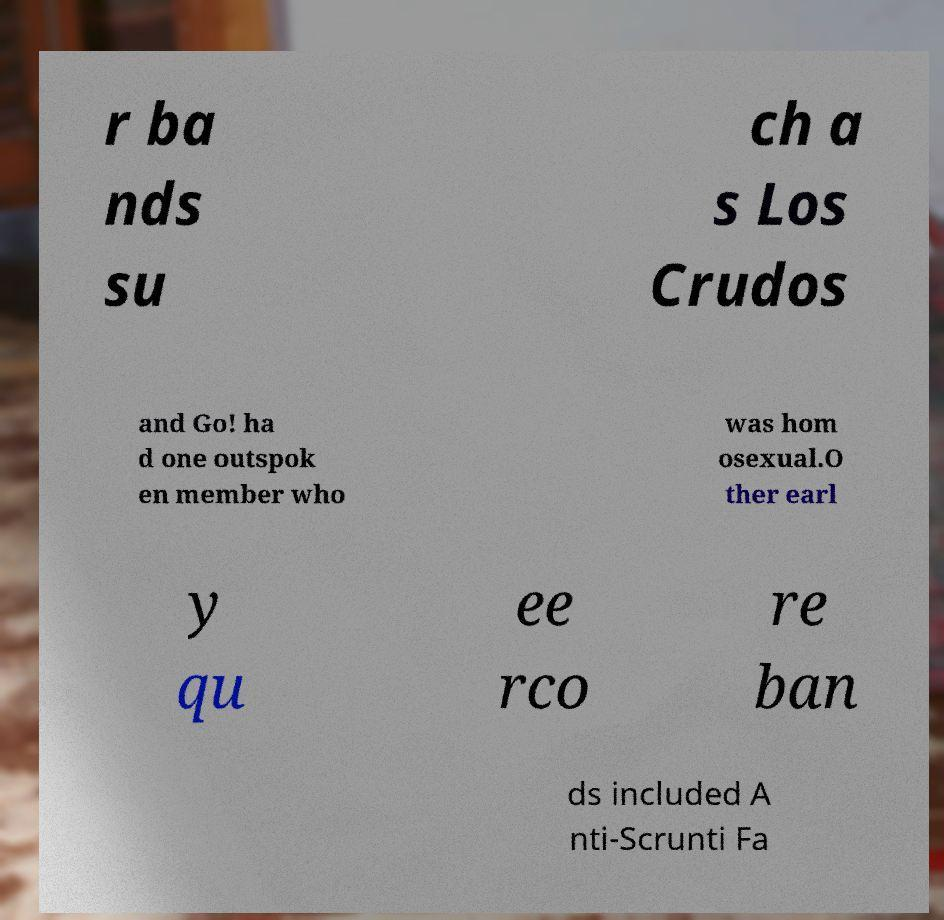What messages or text are displayed in this image? I need them in a readable, typed format. r ba nds su ch a s Los Crudos and Go! ha d one outspok en member who was hom osexual.O ther earl y qu ee rco re ban ds included A nti-Scrunti Fa 